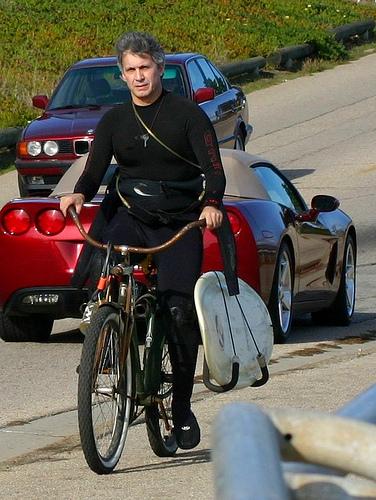What is the man sitting on?
Give a very brief answer. Bicycle. What type of transportation?
Concise answer only. Bike. What is resting on the cycle's handlebars?
Keep it brief. Hands. How many cars are visible?
Give a very brief answer. 2. How many men are there?
Keep it brief. 1. Is this person wearing a shirt?
Give a very brief answer. Yes. Does the man have sleeves on?
Short answer required. Yes. What is the man in black riding?
Concise answer only. Bike. What color is the bicycle?
Answer briefly. Brown. What is he carrying on the bicycle?
Answer briefly. Surfboard. Where are the trouser protectors?
Be succinct. Legs. What is the make of the motorcycle?
Be succinct. Schwinn. What is the boy riding on?
Quick response, please. Bicycle. Is the man wearing glasses?
Keep it brief. No. Is one of the cars a BMW?
Quick response, please. Yes. What are men wearing on their heads?
Write a very short answer. Nothing. 